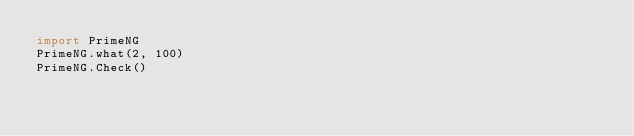<code> <loc_0><loc_0><loc_500><loc_500><_Python_>import PrimeNG
PrimeNG.what(2, 100)
PrimeNG.Check()
</code> 